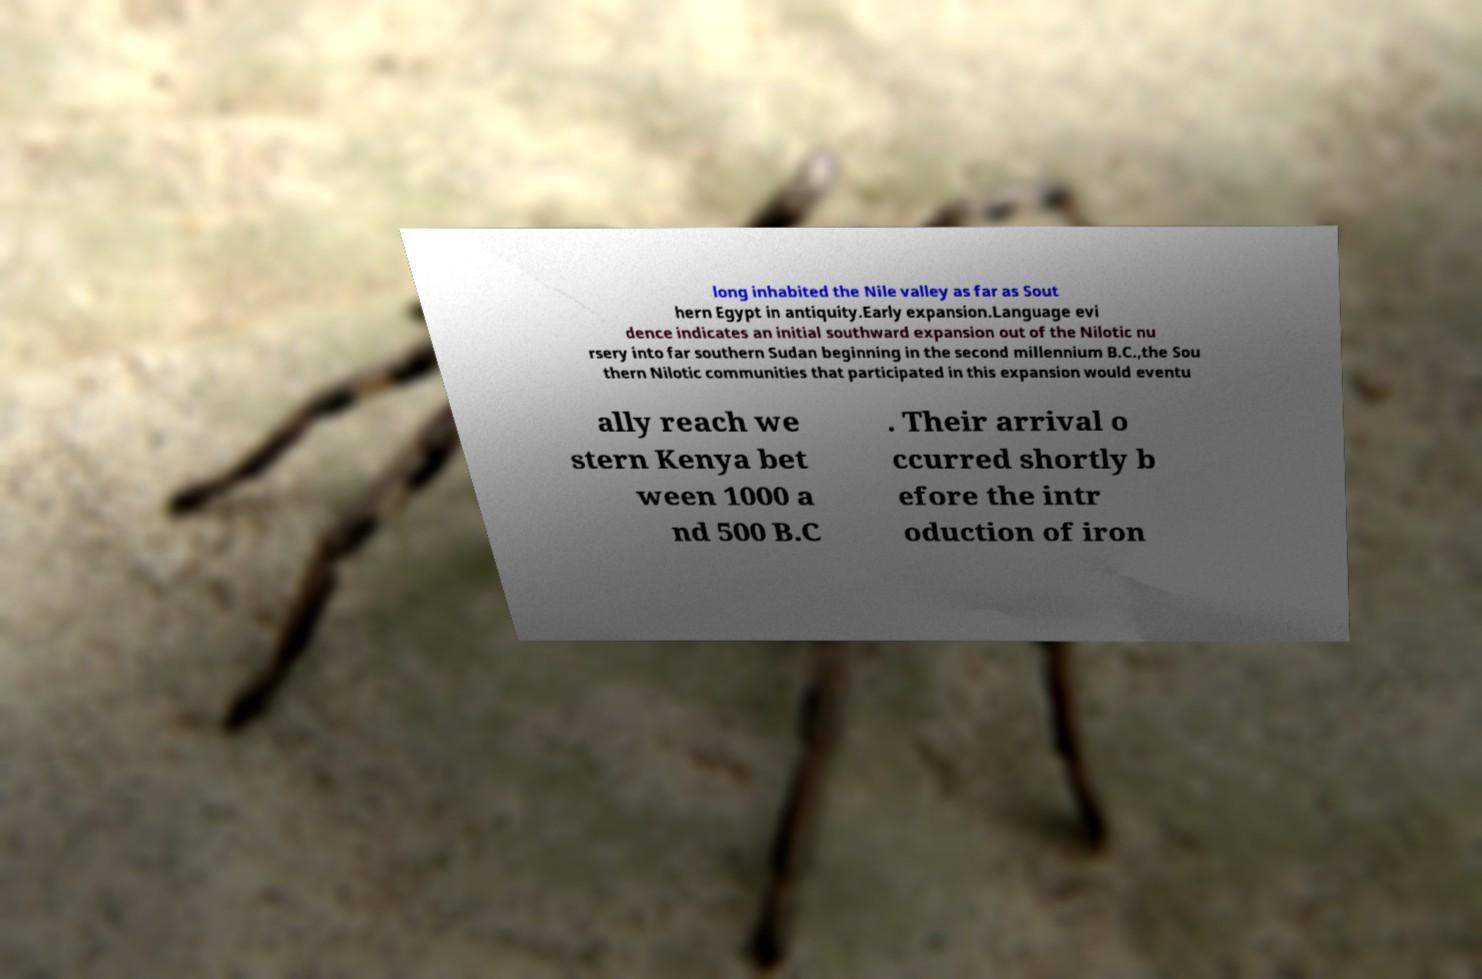Please identify and transcribe the text found in this image. long inhabited the Nile valley as far as Sout hern Egypt in antiquity.Early expansion.Language evi dence indicates an initial southward expansion out of the Nilotic nu rsery into far southern Sudan beginning in the second millennium B.C.,the Sou thern Nilotic communities that participated in this expansion would eventu ally reach we stern Kenya bet ween 1000 a nd 500 B.C . Their arrival o ccurred shortly b efore the intr oduction of iron 